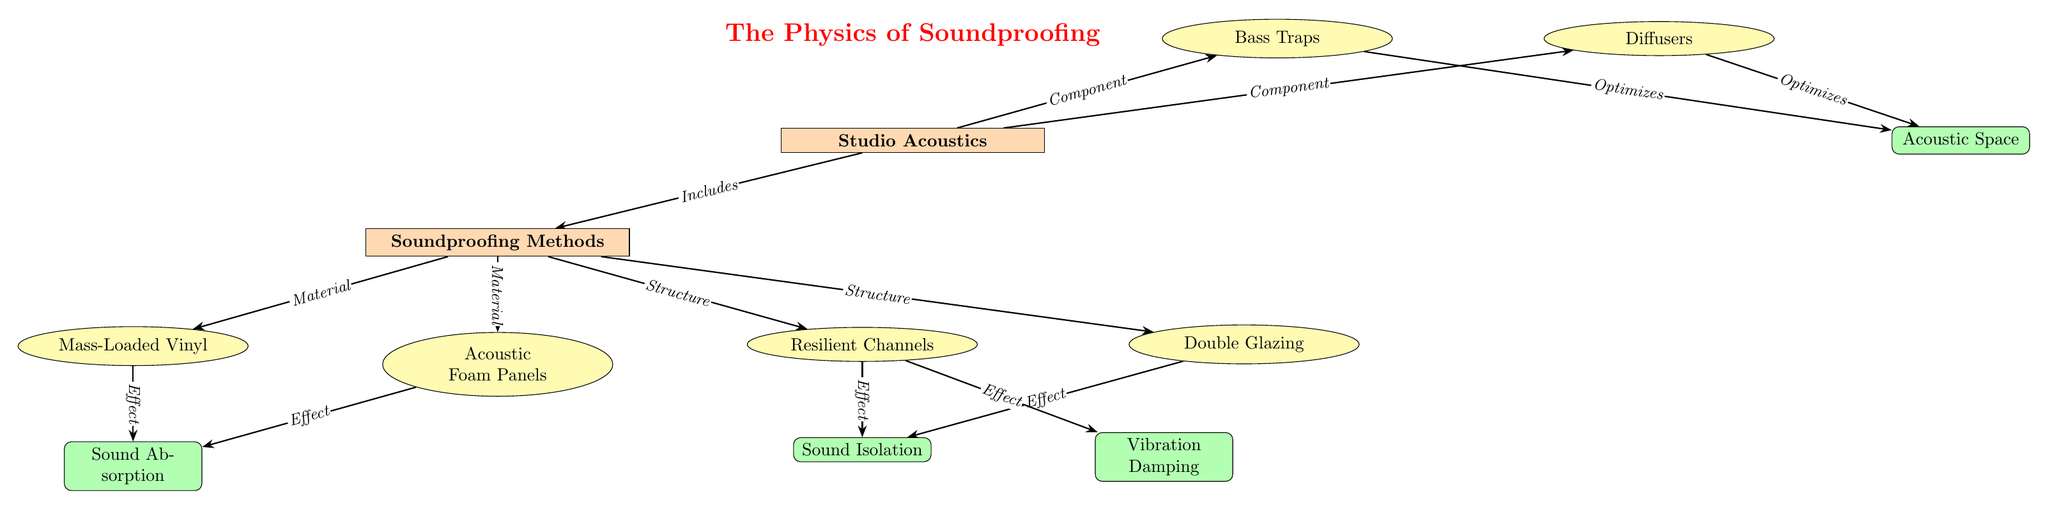What are the four soundproofing methods listed in the diagram? The diagram lists four soundproofing methods: Mass-Loaded Vinyl, Acoustic Foam Panels, Resilient Channels, and Double Glazing.
Answer: Mass-Loaded Vinyl, Acoustic Foam Panels, Resilient Channels, Double Glazing Which soundproofing method is categorized as a material? The diagram categorizes Mass-Loaded Vinyl and Acoustic Foam Panels as materials, while Resilient Channels and Double Glazing are classified as structures.
Answer: Mass-Loaded Vinyl, Acoustic Foam Panels What effect do Sound Absorption methods have according to the diagram? The diagram shows that both Mass-Loaded Vinyl and Acoustic Foam Panels lead to the effect of Sound Absorption.
Answer: Sound Absorption What are the two components of Studio Acoustics? The diagram indicates that Bass Traps and Diffusers are the two components that make up Studio Acoustics.
Answer: Bass Traps, Diffusers How does the structure Resilient Channels affect sound isolation? Resilient Channels contribute to the effect of Sound Isolation as shown in the connections within the diagram.
Answer: Sound Isolation What two optimizations do Bass Traps and Diffusers provide in the diagram? The diagram indicates that both Bass Traps and Diffusers optimize the Acoustic Space, which is their shared function.
Answer: Acoustic Space How many edges connect to the node Soundproofing Methods? The diagram shows that there are four edges connecting to the Soundproofing Methods node, reflecting the four methods listed.
Answer: 4 What is the relationship between Studio Acoustics and Soundproofing Methods? Studio Acoustics includes Soundproofing Methods as an essential part of its structure, as indicated by the connection in the diagram.
Answer: Includes 